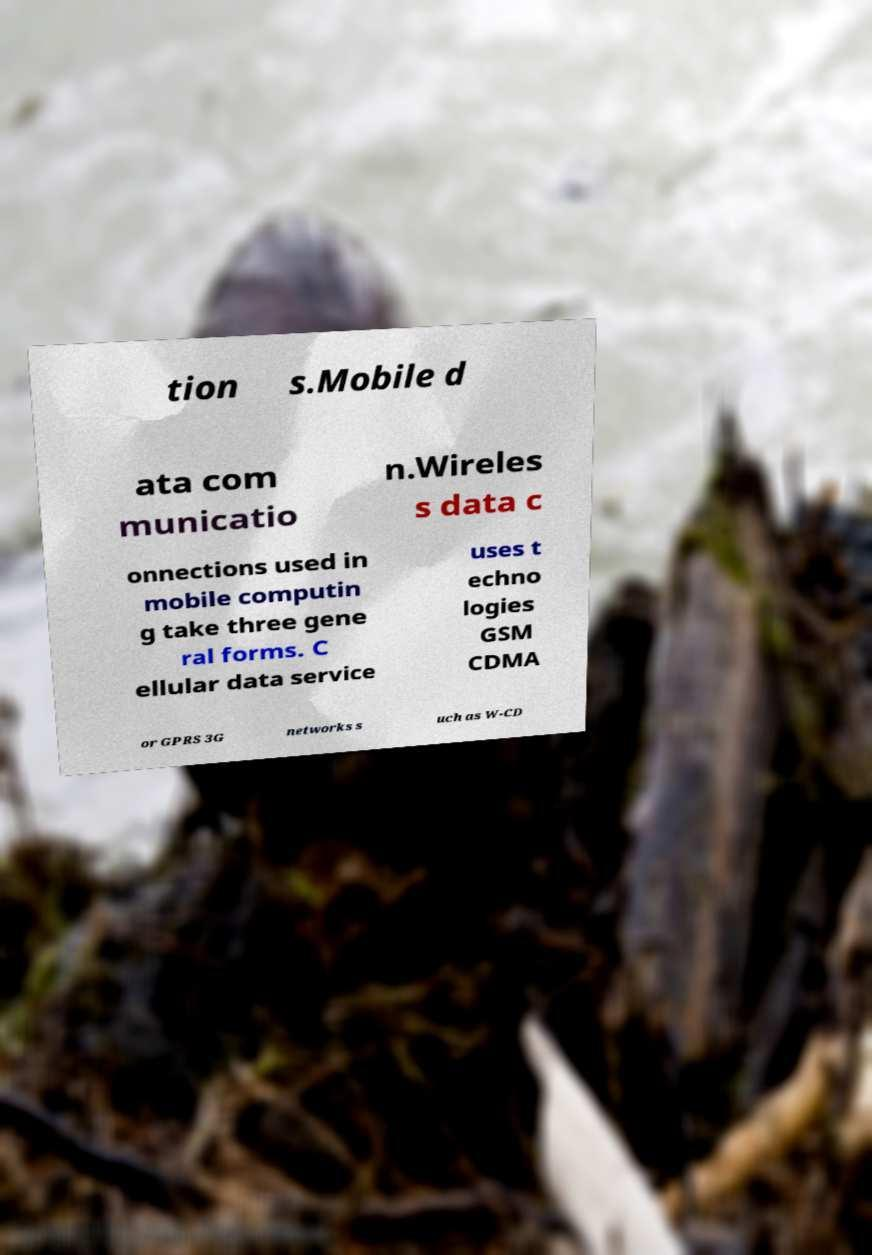What messages or text are displayed in this image? I need them in a readable, typed format. tion s.Mobile d ata com municatio n.Wireles s data c onnections used in mobile computin g take three gene ral forms. C ellular data service uses t echno logies GSM CDMA or GPRS 3G networks s uch as W-CD 